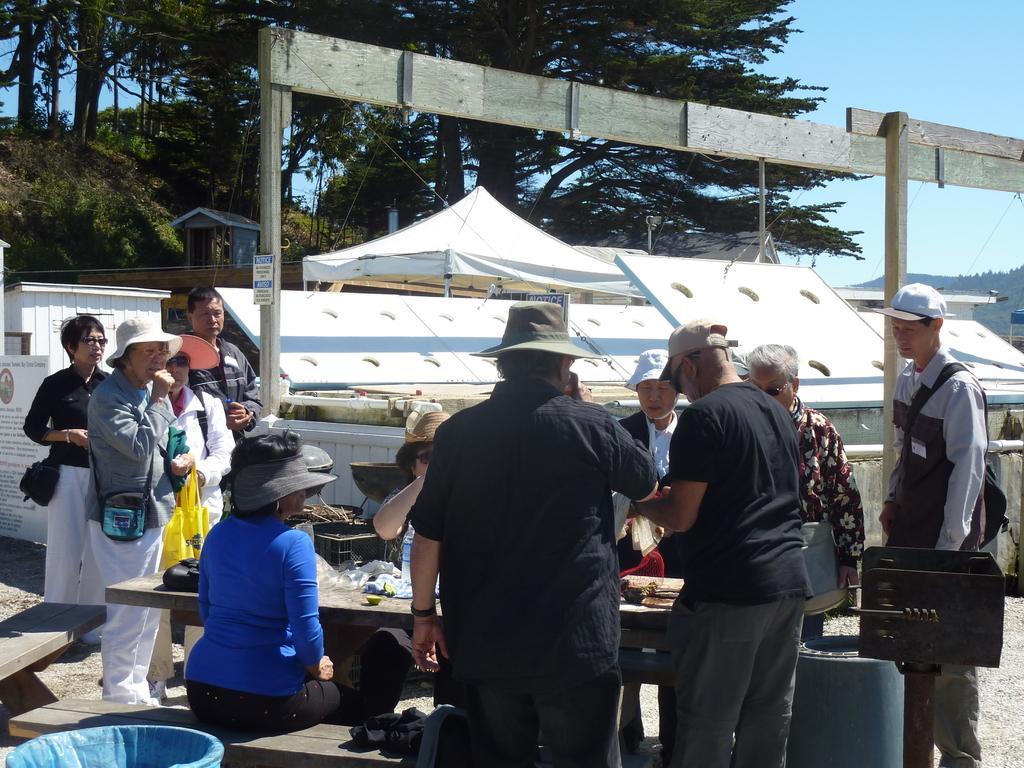In one or two sentences, can you explain what this image depicts? In this image in the foreground there is a table, on which there is a bottle, bag, some other objects, there are few persons visible around the table, there is a barrel, container, bench, in the middle there are some trees, tents, fence, in the top right there is the sky. 